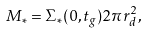<formula> <loc_0><loc_0><loc_500><loc_500>M _ { * } = \Sigma _ { * } ( 0 , t _ { g } ) 2 \pi r _ { d } ^ { 2 } ,</formula> 